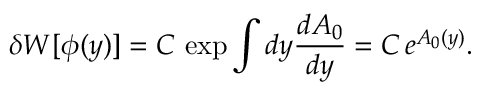Convert formula to latex. <formula><loc_0><loc_0><loc_500><loc_500>\delta W [ \phi ( y ) ] = C \, \exp \int d y \frac { d A _ { 0 } } { d y } = C \, e ^ { A _ { 0 } ( y ) } .</formula> 